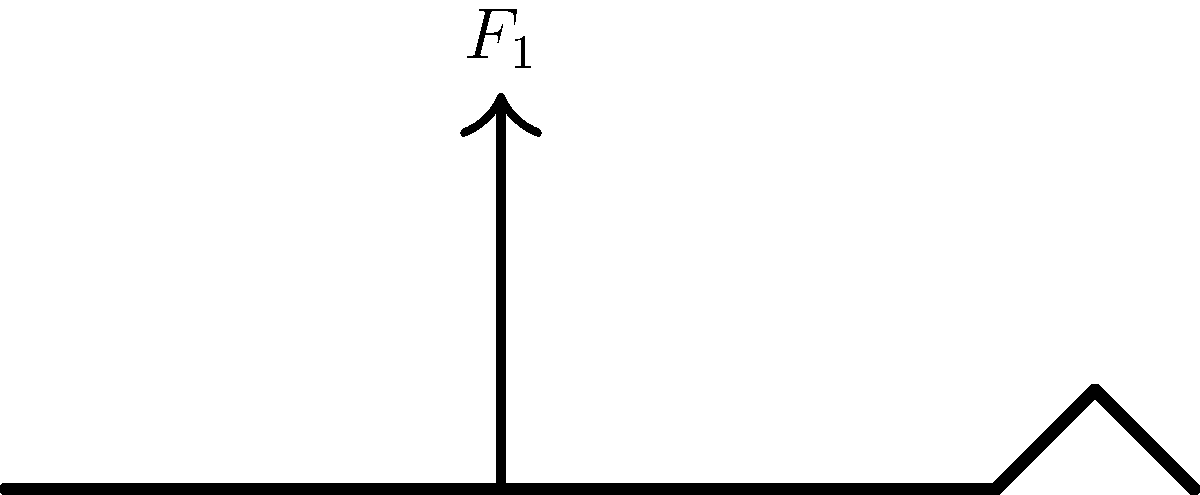In the protagonist's signature sword-fighting move, three forces ($F_1$, $F_2$, and $F_3$) are applied to the sword as shown in the diagram. If $F_1 = 100$ N, $F_2 = 80$ N, and the angle between $F_1$ and $F_2$ is 30°, calculate the magnitude of $F_3$ required to maintain equilibrium. To solve this problem, we'll follow these steps:

1. Recognize that for equilibrium, the sum of all forces must be zero: $\sum \vec{F} = 0$.

2. Break down the forces into their x and y components:
   $F_{1x} = 0$, $F_{1y} = 100$ N
   $F_{2x} = 80 \cos(30°)$, $F_{2y} = 80 \sin(30°)$

3. Let the unknown force $F_3$ have components $F_{3x}$ and $F_{3y}$.

4. Set up equations for equilibrium in x and y directions:
   x-direction: $F_{2x} + F_{3x} = 0$
   y-direction: $F_{1y} + F_{2y} + F_{3y} = 0$

5. Solve for $F_{3x}$ and $F_{3y}$:
   $F_{3x} = -F_{2x} = -80 \cos(30°) = -69.28$ N
   $F_{3y} = -F_{1y} - F_{2y} = -100 - 80 \sin(30°) = -140$ N

6. Calculate the magnitude of $F_3$ using the Pythagorean theorem:
   $F_3 = \sqrt{F_{3x}^2 + F_{3y}^2} = \sqrt{(-69.28)^2 + (-140)^2} = 156.2$ N

Therefore, the magnitude of $F_3$ required to maintain equilibrium is approximately 156.2 N.
Answer: 156.2 N 